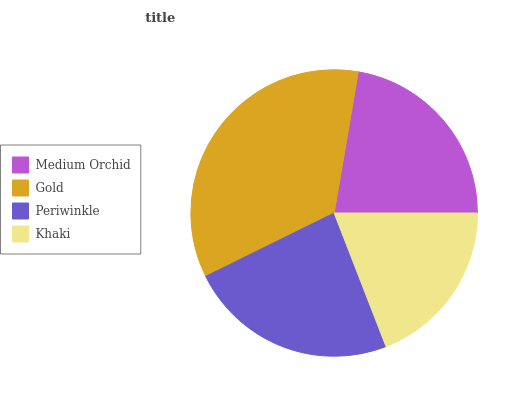Is Khaki the minimum?
Answer yes or no. Yes. Is Gold the maximum?
Answer yes or no. Yes. Is Periwinkle the minimum?
Answer yes or no. No. Is Periwinkle the maximum?
Answer yes or no. No. Is Gold greater than Periwinkle?
Answer yes or no. Yes. Is Periwinkle less than Gold?
Answer yes or no. Yes. Is Periwinkle greater than Gold?
Answer yes or no. No. Is Gold less than Periwinkle?
Answer yes or no. No. Is Periwinkle the high median?
Answer yes or no. Yes. Is Medium Orchid the low median?
Answer yes or no. Yes. Is Medium Orchid the high median?
Answer yes or no. No. Is Periwinkle the low median?
Answer yes or no. No. 